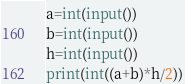Convert code to text. <code><loc_0><loc_0><loc_500><loc_500><_Python_>a=int(input())
b=int(input())
h=int(input())
print(int((a+b)*h/2))</code> 